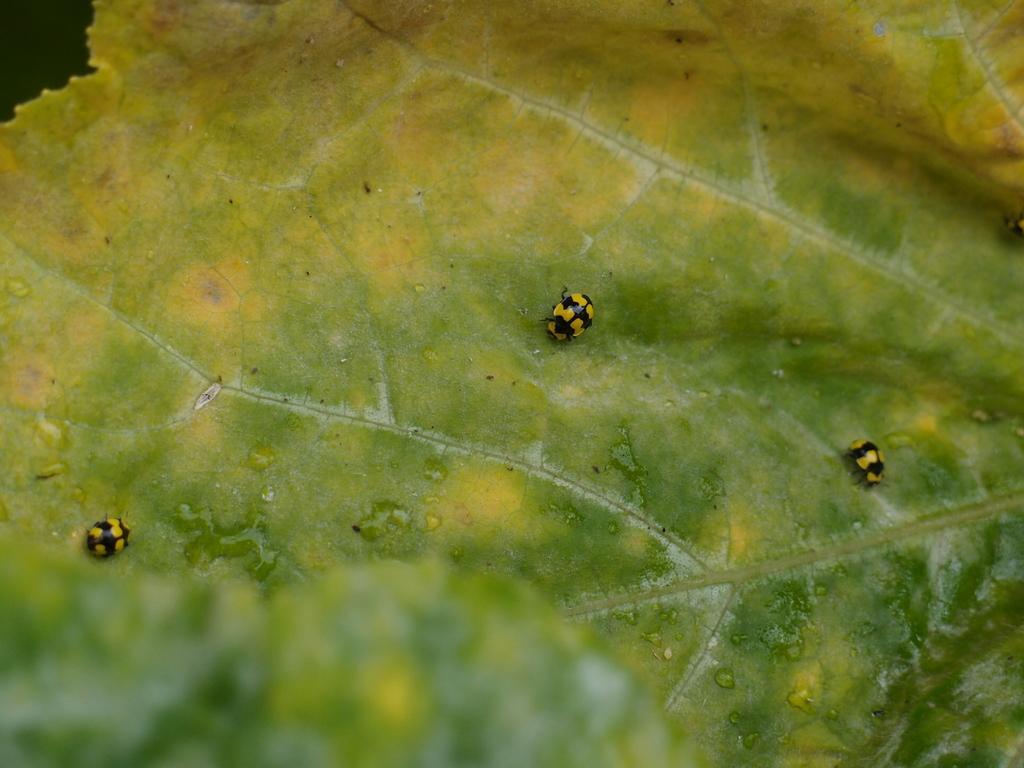Can you describe this image briefly? In this image I can see insects are on the leaf.   